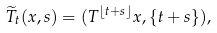Convert formula to latex. <formula><loc_0><loc_0><loc_500><loc_500>\widetilde { T } _ { t } ( x , s ) = ( T ^ { \lfloor t + s \rfloor } x , \{ t + s \} ) ,</formula> 